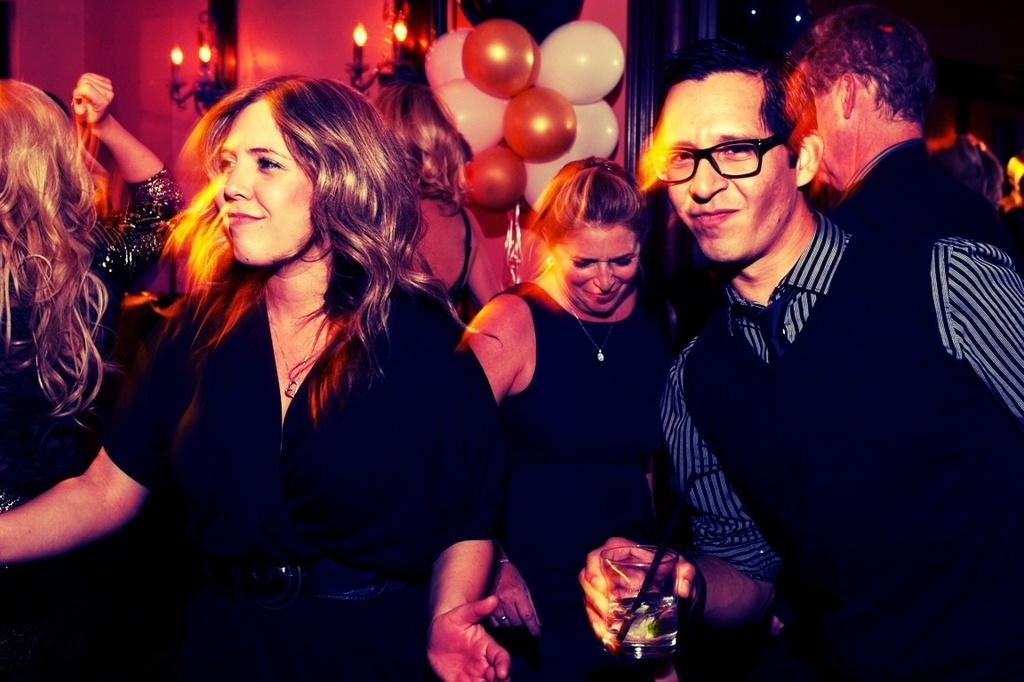What are the people in the image doing? The people in the image are dancing. Can you describe what one of the people is holding? One of the people is holding a glass of drink. What can be seen in the background of the image? There is a wall in the background of the image. How is the wall decorated? The wall is decorated with candles and balloons. Where is the boat located in the image? There is no boat present in the image. What type of drawer can be seen in the image? There is no drawer present in the image. 